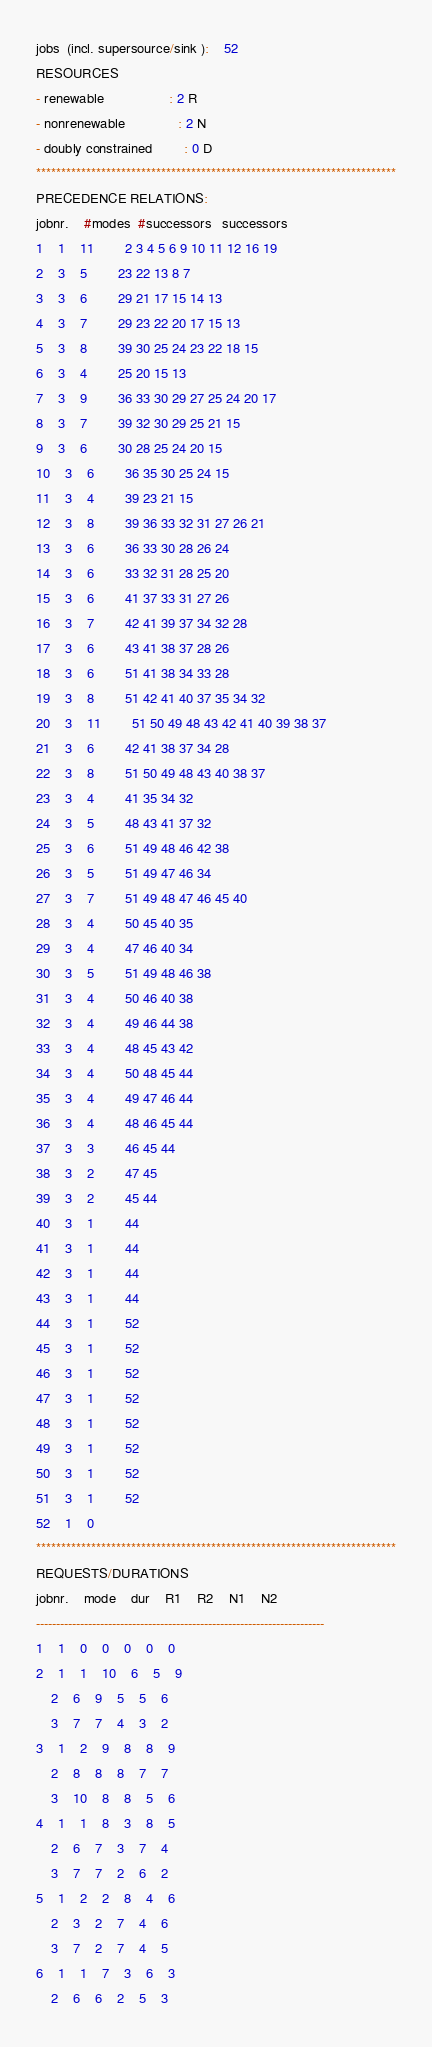Convert code to text. <code><loc_0><loc_0><loc_500><loc_500><_ObjectiveC_>jobs  (incl. supersource/sink ):	52
RESOURCES
- renewable                 : 2 R
- nonrenewable              : 2 N
- doubly constrained        : 0 D
************************************************************************
PRECEDENCE RELATIONS:
jobnr.    #modes  #successors   successors
1	1	11		2 3 4 5 6 9 10 11 12 16 19 
2	3	5		23 22 13 8 7 
3	3	6		29 21 17 15 14 13 
4	3	7		29 23 22 20 17 15 13 
5	3	8		39 30 25 24 23 22 18 15 
6	3	4		25 20 15 13 
7	3	9		36 33 30 29 27 25 24 20 17 
8	3	7		39 32 30 29 25 21 15 
9	3	6		30 28 25 24 20 15 
10	3	6		36 35 30 25 24 15 
11	3	4		39 23 21 15 
12	3	8		39 36 33 32 31 27 26 21 
13	3	6		36 33 30 28 26 24 
14	3	6		33 32 31 28 25 20 
15	3	6		41 37 33 31 27 26 
16	3	7		42 41 39 37 34 32 28 
17	3	6		43 41 38 37 28 26 
18	3	6		51 41 38 34 33 28 
19	3	8		51 42 41 40 37 35 34 32 
20	3	11		51 50 49 48 43 42 41 40 39 38 37 
21	3	6		42 41 38 37 34 28 
22	3	8		51 50 49 48 43 40 38 37 
23	3	4		41 35 34 32 
24	3	5		48 43 41 37 32 
25	3	6		51 49 48 46 42 38 
26	3	5		51 49 47 46 34 
27	3	7		51 49 48 47 46 45 40 
28	3	4		50 45 40 35 
29	3	4		47 46 40 34 
30	3	5		51 49 48 46 38 
31	3	4		50 46 40 38 
32	3	4		49 46 44 38 
33	3	4		48 45 43 42 
34	3	4		50 48 45 44 
35	3	4		49 47 46 44 
36	3	4		48 46 45 44 
37	3	3		46 45 44 
38	3	2		47 45 
39	3	2		45 44 
40	3	1		44 
41	3	1		44 
42	3	1		44 
43	3	1		44 
44	3	1		52 
45	3	1		52 
46	3	1		52 
47	3	1		52 
48	3	1		52 
49	3	1		52 
50	3	1		52 
51	3	1		52 
52	1	0		
************************************************************************
REQUESTS/DURATIONS
jobnr.	mode	dur	R1	R2	N1	N2	
------------------------------------------------------------------------
1	1	0	0	0	0	0	
2	1	1	10	6	5	9	
	2	6	9	5	5	6	
	3	7	7	4	3	2	
3	1	2	9	8	8	9	
	2	8	8	8	7	7	
	3	10	8	8	5	6	
4	1	1	8	3	8	5	
	2	6	7	3	7	4	
	3	7	7	2	6	2	
5	1	2	2	8	4	6	
	2	3	2	7	4	6	
	3	7	2	7	4	5	
6	1	1	7	3	6	3	
	2	6	6	2	5	3	</code> 